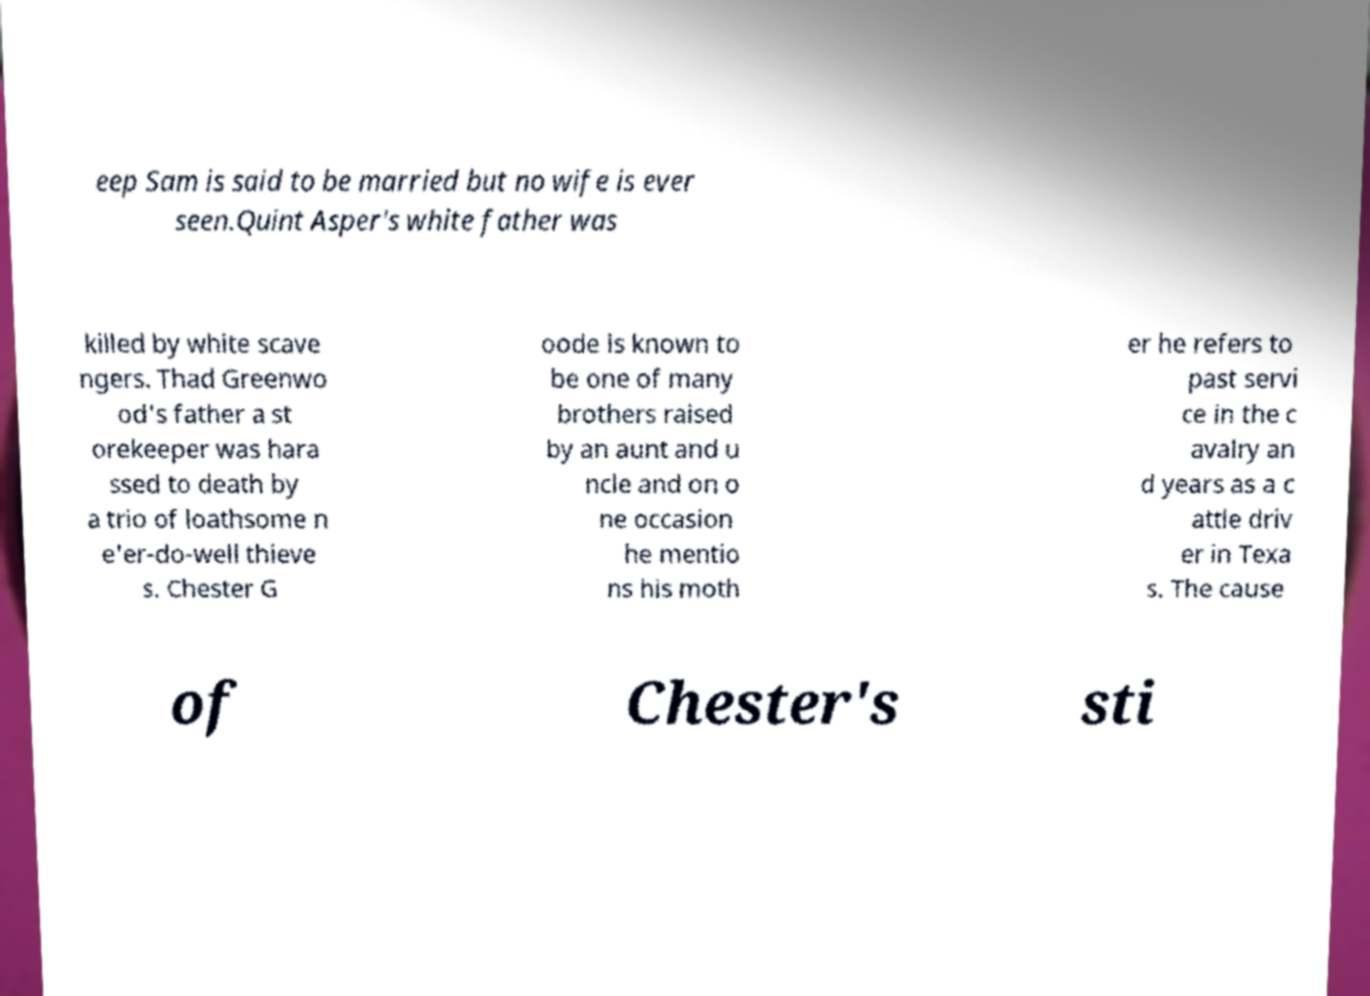Could you assist in decoding the text presented in this image and type it out clearly? eep Sam is said to be married but no wife is ever seen.Quint Asper's white father was killed by white scave ngers. Thad Greenwo od's father a st orekeeper was hara ssed to death by a trio of loathsome n e'er-do-well thieve s. Chester G oode is known to be one of many brothers raised by an aunt and u ncle and on o ne occasion he mentio ns his moth er he refers to past servi ce in the c avalry an d years as a c attle driv er in Texa s. The cause of Chester's sti 